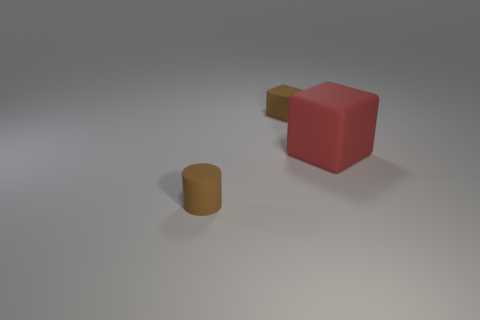Add 3 big objects. How many objects exist? 6 Subtract all cyan cubes. Subtract all gray cylinders. How many cubes are left? 2 Subtract all cylinders. How many objects are left? 2 Add 2 big red rubber things. How many big red rubber things are left? 3 Add 1 big yellow cylinders. How many big yellow cylinders exist? 1 Subtract 0 blue cubes. How many objects are left? 3 Subtract all big gray things. Subtract all big cubes. How many objects are left? 2 